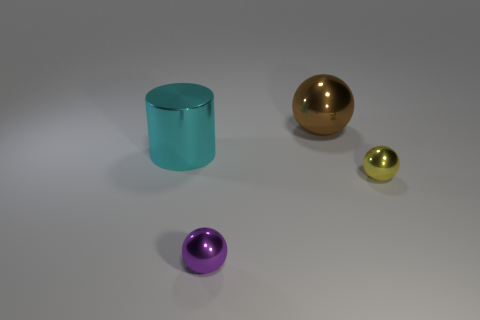Add 3 purple cylinders. How many objects exist? 7 Subtract all spheres. How many objects are left? 1 Add 1 big cylinders. How many big cylinders exist? 2 Subtract 0 gray balls. How many objects are left? 4 Subtract all blue metal cylinders. Subtract all tiny things. How many objects are left? 2 Add 2 big cyan objects. How many big cyan objects are left? 3 